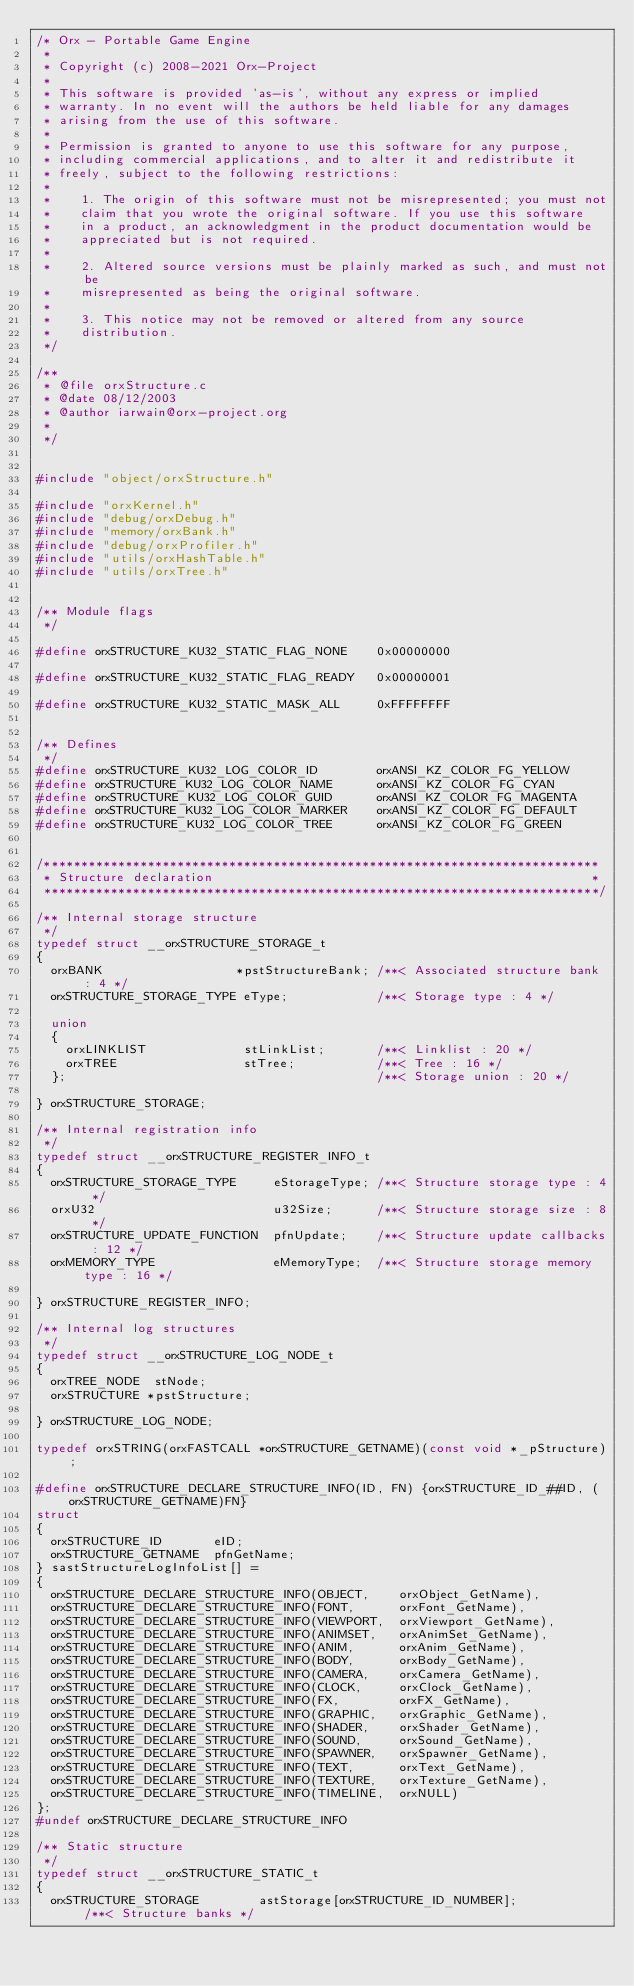<code> <loc_0><loc_0><loc_500><loc_500><_C_>/* Orx - Portable Game Engine
 *
 * Copyright (c) 2008-2021 Orx-Project
 *
 * This software is provided 'as-is', without any express or implied
 * warranty. In no event will the authors be held liable for any damages
 * arising from the use of this software.
 *
 * Permission is granted to anyone to use this software for any purpose,
 * including commercial applications, and to alter it and redistribute it
 * freely, subject to the following restrictions:
 *
 *    1. The origin of this software must not be misrepresented; you must not
 *    claim that you wrote the original software. If you use this software
 *    in a product, an acknowledgment in the product documentation would be
 *    appreciated but is not required.
 *
 *    2. Altered source versions must be plainly marked as such, and must not be
 *    misrepresented as being the original software.
 *
 *    3. This notice may not be removed or altered from any source
 *    distribution.
 */

/**
 * @file orxStructure.c
 * @date 08/12/2003
 * @author iarwain@orx-project.org
 *
 */


#include "object/orxStructure.h"

#include "orxKernel.h"
#include "debug/orxDebug.h"
#include "memory/orxBank.h"
#include "debug/orxProfiler.h"
#include "utils/orxHashTable.h"
#include "utils/orxTree.h"


/** Module flags
 */

#define orxSTRUCTURE_KU32_STATIC_FLAG_NONE    0x00000000

#define orxSTRUCTURE_KU32_STATIC_FLAG_READY   0x00000001

#define orxSTRUCTURE_KU32_STATIC_MASK_ALL     0xFFFFFFFF


/** Defines
 */
#define orxSTRUCTURE_KU32_LOG_COLOR_ID        orxANSI_KZ_COLOR_FG_YELLOW
#define orxSTRUCTURE_KU32_LOG_COLOR_NAME      orxANSI_KZ_COLOR_FG_CYAN
#define orxSTRUCTURE_KU32_LOG_COLOR_GUID      orxANSI_KZ_COLOR_FG_MAGENTA
#define orxSTRUCTURE_KU32_LOG_COLOR_MARKER    orxANSI_KZ_COLOR_FG_DEFAULT
#define orxSTRUCTURE_KU32_LOG_COLOR_TREE      orxANSI_KZ_COLOR_FG_GREEN


/***************************************************************************
 * Structure declaration                                                   *
 ***************************************************************************/

/** Internal storage structure
 */
typedef struct __orxSTRUCTURE_STORAGE_t
{
  orxBANK                  *pstStructureBank; /**< Associated structure bank : 4 */
  orxSTRUCTURE_STORAGE_TYPE eType;            /**< Storage type : 4 */

  union
  {
    orxLINKLIST             stLinkList;       /**< Linklist : 20 */
    orxTREE                 stTree;           /**< Tree : 16 */
  };                                          /**< Storage union : 20 */

} orxSTRUCTURE_STORAGE;

/** Internal registration info
 */
typedef struct __orxSTRUCTURE_REGISTER_INFO_t
{
  orxSTRUCTURE_STORAGE_TYPE     eStorageType; /**< Structure storage type : 4 */
  orxU32                        u32Size;      /**< Structure storage size : 8 */
  orxSTRUCTURE_UPDATE_FUNCTION  pfnUpdate;    /**< Structure update callbacks : 12 */
  orxMEMORY_TYPE                eMemoryType;  /**< Structure storage memory type : 16 */

} orxSTRUCTURE_REGISTER_INFO;

/** Internal log structures
 */
typedef struct __orxSTRUCTURE_LOG_NODE_t
{
  orxTREE_NODE  stNode;
  orxSTRUCTURE *pstStructure;

} orxSTRUCTURE_LOG_NODE;

typedef orxSTRING(orxFASTCALL *orxSTRUCTURE_GETNAME)(const void *_pStructure);

#define orxSTRUCTURE_DECLARE_STRUCTURE_INFO(ID, FN) {orxSTRUCTURE_ID_##ID, (orxSTRUCTURE_GETNAME)FN}
struct
{
  orxSTRUCTURE_ID       eID;
  orxSTRUCTURE_GETNAME  pfnGetName;
} sastStructureLogInfoList[] =
{
  orxSTRUCTURE_DECLARE_STRUCTURE_INFO(OBJECT,    orxObject_GetName),
  orxSTRUCTURE_DECLARE_STRUCTURE_INFO(FONT,      orxFont_GetName),
  orxSTRUCTURE_DECLARE_STRUCTURE_INFO(VIEWPORT,  orxViewport_GetName),
  orxSTRUCTURE_DECLARE_STRUCTURE_INFO(ANIMSET,   orxAnimSet_GetName),
  orxSTRUCTURE_DECLARE_STRUCTURE_INFO(ANIM,      orxAnim_GetName),
  orxSTRUCTURE_DECLARE_STRUCTURE_INFO(BODY,      orxBody_GetName),
  orxSTRUCTURE_DECLARE_STRUCTURE_INFO(CAMERA,    orxCamera_GetName),
  orxSTRUCTURE_DECLARE_STRUCTURE_INFO(CLOCK,     orxClock_GetName),
  orxSTRUCTURE_DECLARE_STRUCTURE_INFO(FX,        orxFX_GetName),
  orxSTRUCTURE_DECLARE_STRUCTURE_INFO(GRAPHIC,   orxGraphic_GetName),
  orxSTRUCTURE_DECLARE_STRUCTURE_INFO(SHADER,    orxShader_GetName),
  orxSTRUCTURE_DECLARE_STRUCTURE_INFO(SOUND,     orxSound_GetName),
  orxSTRUCTURE_DECLARE_STRUCTURE_INFO(SPAWNER,   orxSpawner_GetName),
  orxSTRUCTURE_DECLARE_STRUCTURE_INFO(TEXT,      orxText_GetName),
  orxSTRUCTURE_DECLARE_STRUCTURE_INFO(TEXTURE,   orxTexture_GetName),
  orxSTRUCTURE_DECLARE_STRUCTURE_INFO(TIMELINE,  orxNULL)
};
#undef orxSTRUCTURE_DECLARE_STRUCTURE_INFO

/** Static structure
 */
typedef struct __orxSTRUCTURE_STATIC_t
{
  orxSTRUCTURE_STORAGE        astStorage[orxSTRUCTURE_ID_NUMBER];           /**< Structure banks */</code> 